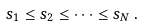<formula> <loc_0><loc_0><loc_500><loc_500>s _ { 1 } \leq s _ { 2 } \leq \cdots \leq s _ { N } \, .</formula> 